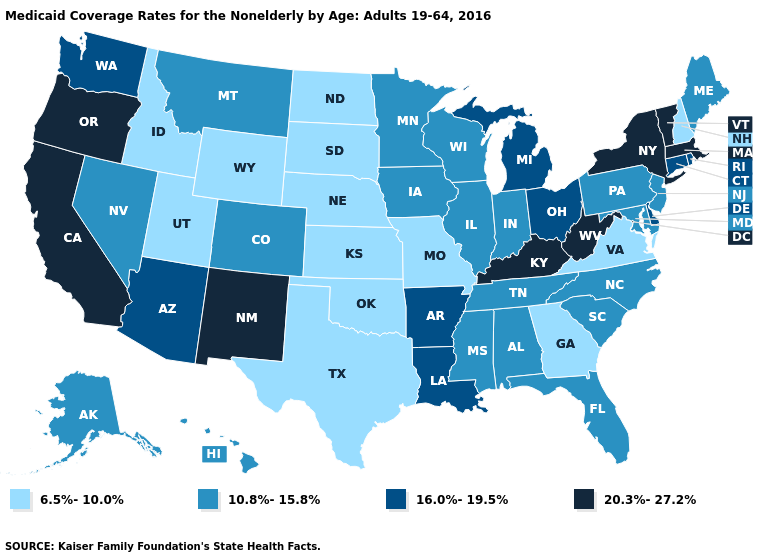What is the value of Missouri?
Concise answer only. 6.5%-10.0%. Does New Jersey have a higher value than Florida?
Give a very brief answer. No. What is the highest value in states that border Texas?
Give a very brief answer. 20.3%-27.2%. Which states have the lowest value in the USA?
Answer briefly. Georgia, Idaho, Kansas, Missouri, Nebraska, New Hampshire, North Dakota, Oklahoma, South Dakota, Texas, Utah, Virginia, Wyoming. Does Florida have a lower value than Oklahoma?
Quick response, please. No. Among the states that border Florida , which have the lowest value?
Concise answer only. Georgia. Does North Dakota have the highest value in the USA?
Quick response, please. No. Does New Hampshire have the lowest value in the USA?
Concise answer only. Yes. What is the lowest value in the USA?
Be succinct. 6.5%-10.0%. What is the value of New Jersey?
Short answer required. 10.8%-15.8%. Name the states that have a value in the range 10.8%-15.8%?
Keep it brief. Alabama, Alaska, Colorado, Florida, Hawaii, Illinois, Indiana, Iowa, Maine, Maryland, Minnesota, Mississippi, Montana, Nevada, New Jersey, North Carolina, Pennsylvania, South Carolina, Tennessee, Wisconsin. What is the value of Alaska?
Answer briefly. 10.8%-15.8%. Does Nevada have the lowest value in the USA?
Write a very short answer. No. Name the states that have a value in the range 20.3%-27.2%?
Answer briefly. California, Kentucky, Massachusetts, New Mexico, New York, Oregon, Vermont, West Virginia. Name the states that have a value in the range 6.5%-10.0%?
Short answer required. Georgia, Idaho, Kansas, Missouri, Nebraska, New Hampshire, North Dakota, Oklahoma, South Dakota, Texas, Utah, Virginia, Wyoming. 